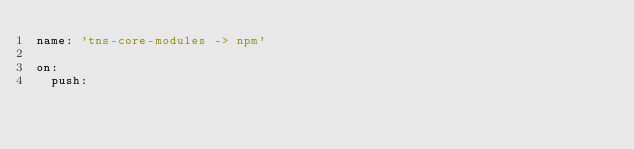<code> <loc_0><loc_0><loc_500><loc_500><_YAML_>name: 'tns-core-modules -> npm'

on:
  push:</code> 